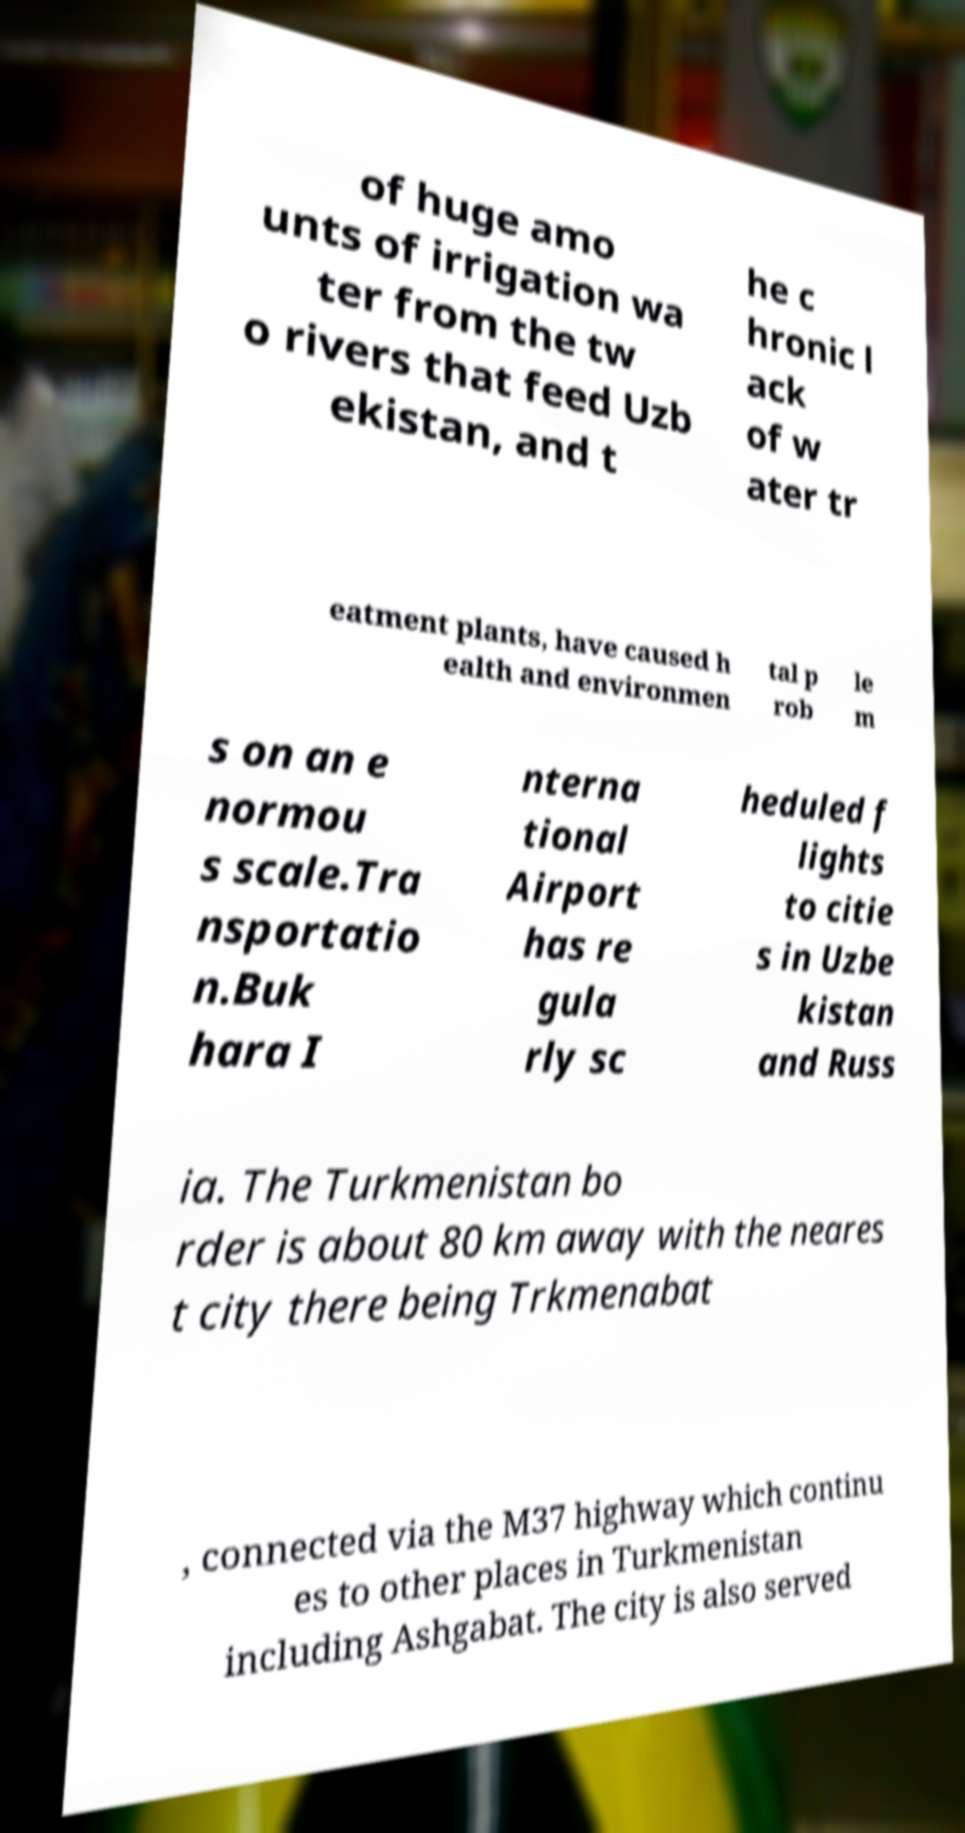I need the written content from this picture converted into text. Can you do that? of huge amo unts of irrigation wa ter from the tw o rivers that feed Uzb ekistan, and t he c hronic l ack of w ater tr eatment plants, have caused h ealth and environmen tal p rob le m s on an e normou s scale.Tra nsportatio n.Buk hara I nterna tional Airport has re gula rly sc heduled f lights to citie s in Uzbe kistan and Russ ia. The Turkmenistan bo rder is about 80 km away with the neares t city there being Trkmenabat , connected via the M37 highway which continu es to other places in Turkmenistan including Ashgabat. The city is also served 